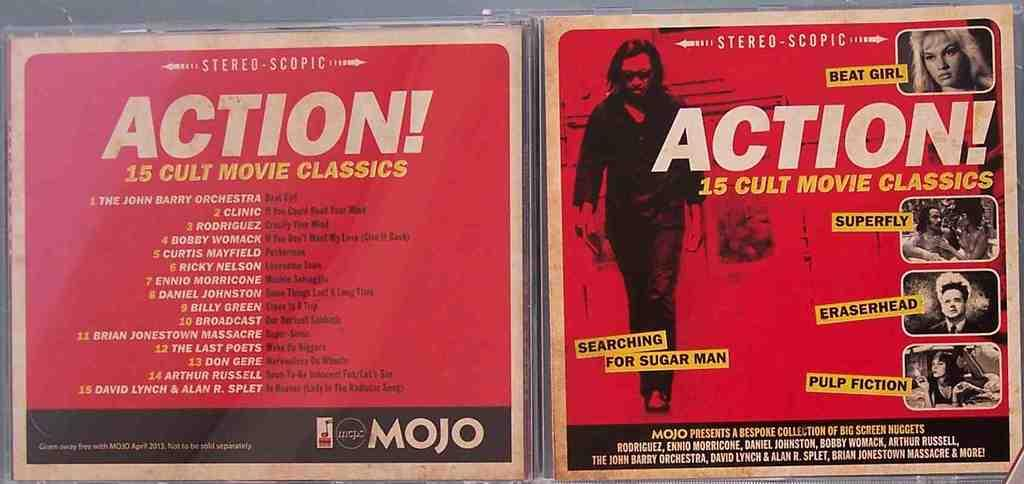<image>
Share a concise interpretation of the image provided. Red white yellow and black action movie classic cover. 